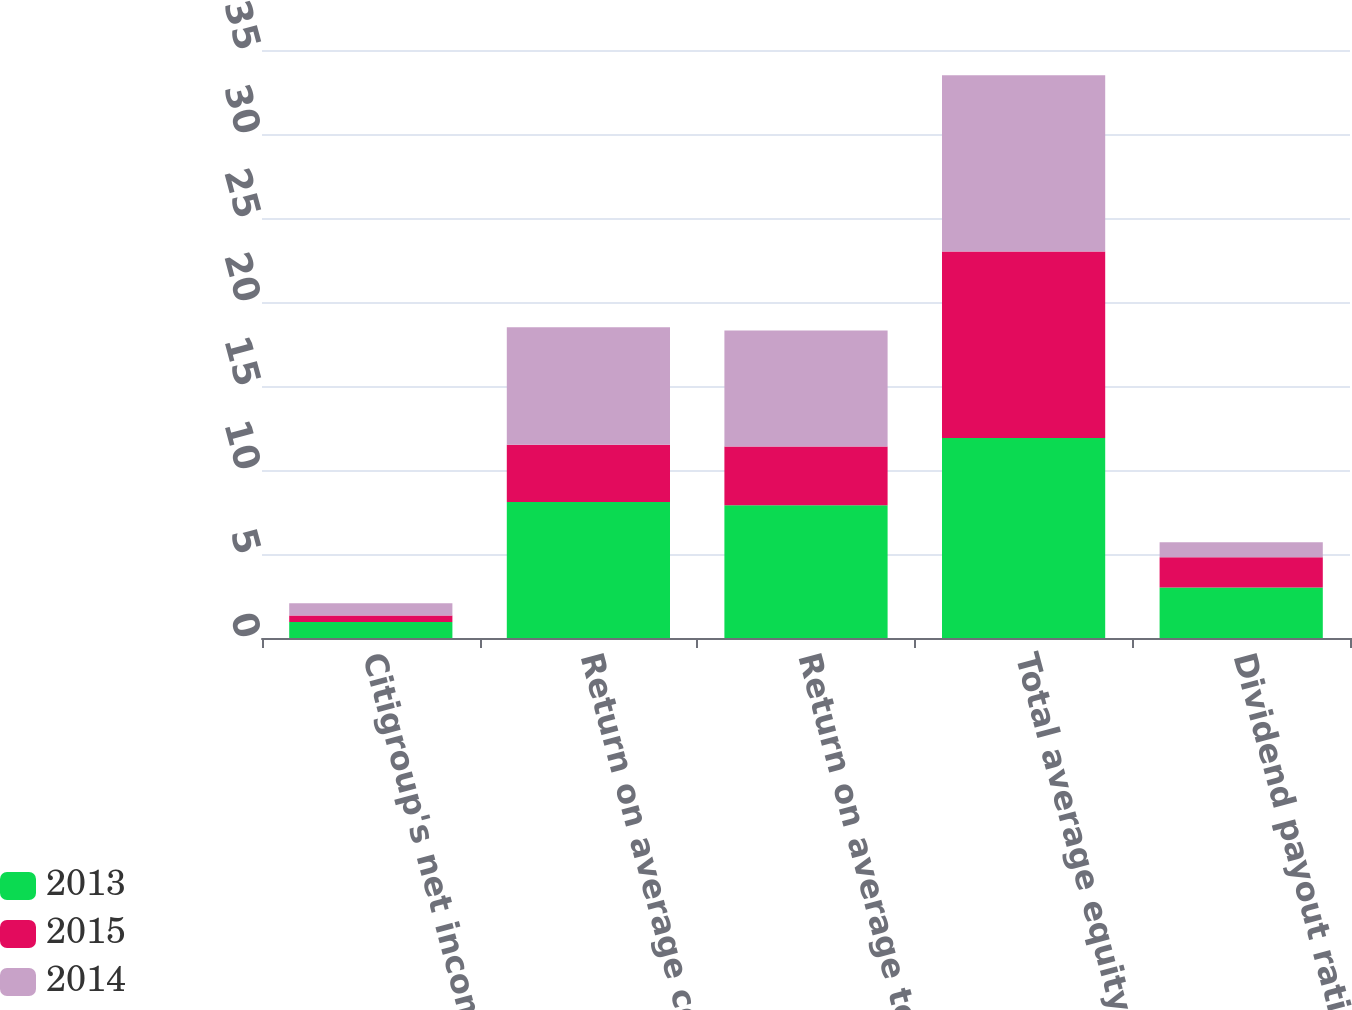<chart> <loc_0><loc_0><loc_500><loc_500><stacked_bar_chart><ecel><fcel>Citigroup's net income to<fcel>Return on average common<fcel>Return on average total<fcel>Total average equity to<fcel>Dividend payout ratio (4)<nl><fcel>2013<fcel>0.95<fcel>8.1<fcel>7.9<fcel>11.9<fcel>3<nl><fcel>2015<fcel>0.39<fcel>3.4<fcel>3.5<fcel>11.1<fcel>1.8<nl><fcel>2014<fcel>0.73<fcel>7<fcel>6.9<fcel>10.5<fcel>0.9<nl></chart> 